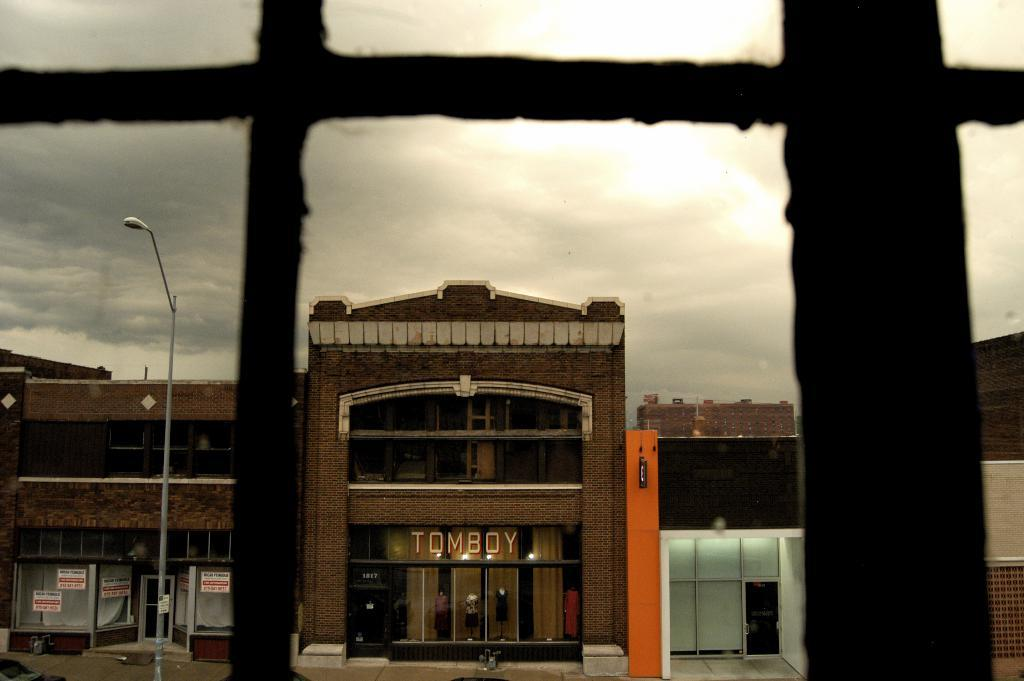What type of structures can be seen in the image? There are buildings in the image. What else is present in the image besides the buildings? There is a road and a pole visible in the image. Can you describe the window in the image? The image shows a window. What is visible at the top of the image? The sky is visible at the top of the image, and it appears to be cloudy. Where is the drawer located in the image? There is no drawer present in the image. Can you describe the yak grazing in the field in the image? There is no yak or field present in the image. 